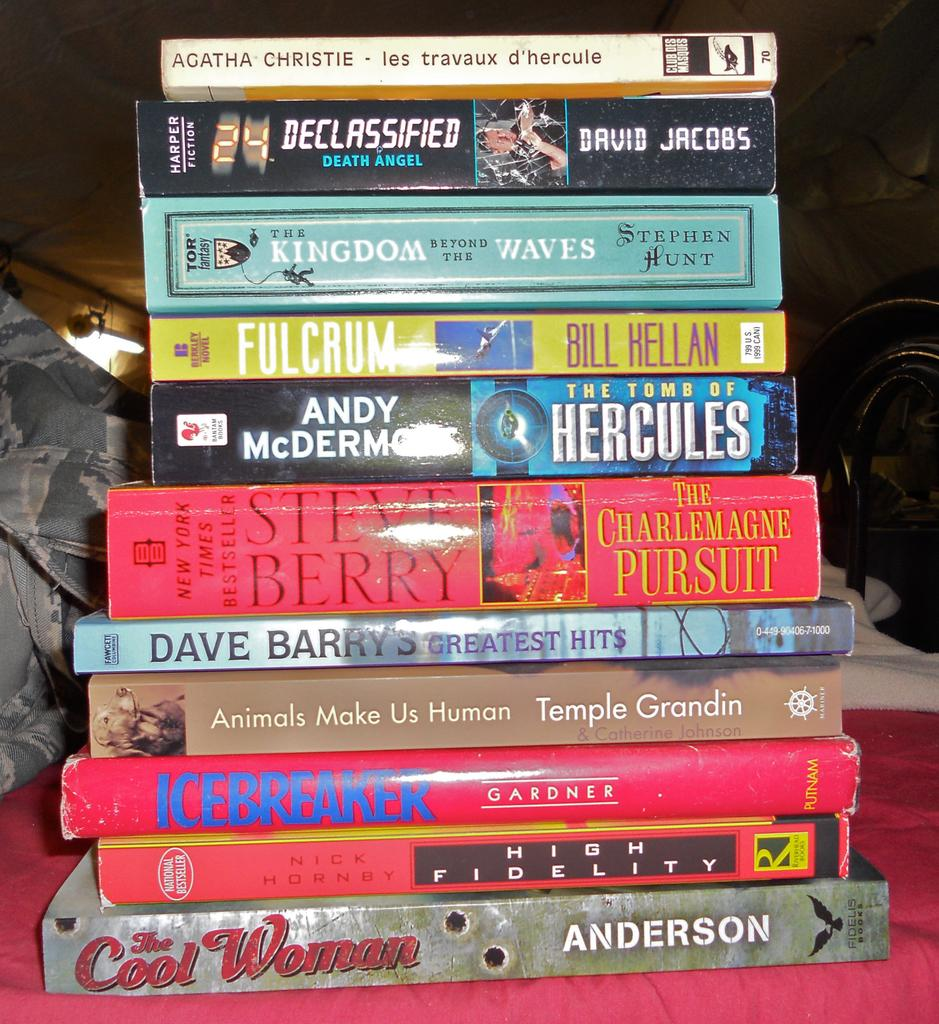<image>
Summarize the visual content of the image. A stack of books including Dave Barry's Greatest Hits. 